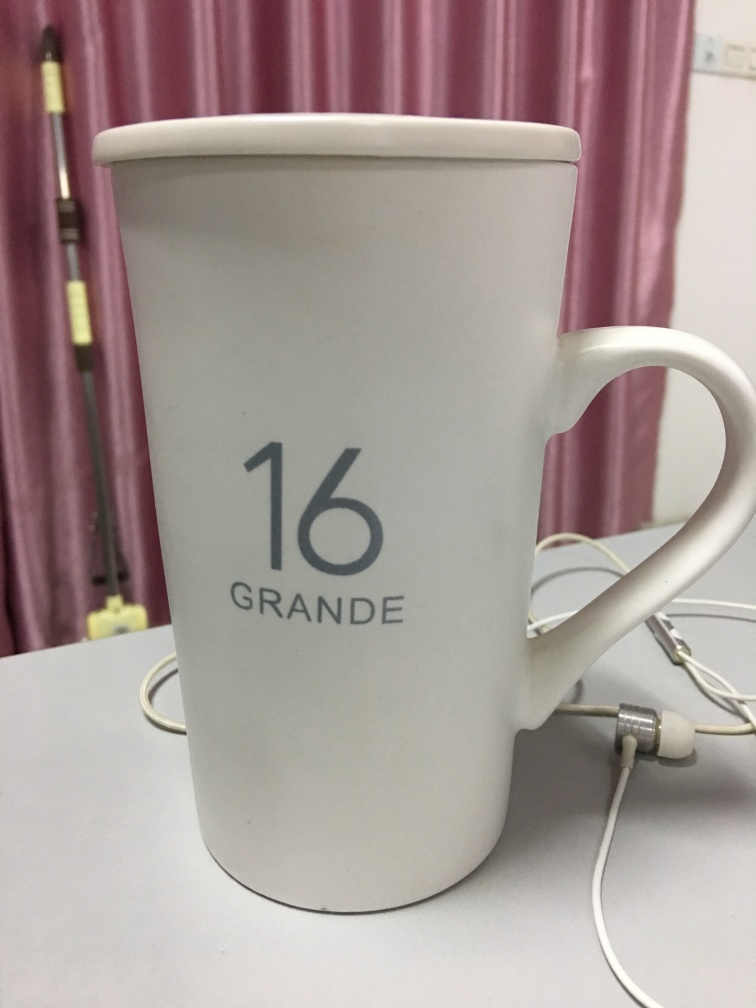What's the mood or style of the setting in which the mug is placed? The image radiates a tranquil and minimalist mood. The simple design of the mug, paired with the clean and uncluttered background, imparts a contemporary style. The pale pink hues of the curtain softens the ambience, creating a feeling of calmness and order. 